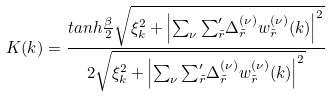Convert formula to latex. <formula><loc_0><loc_0><loc_500><loc_500>K ( { k } ) = \frac { t a n h \frac { \beta } { 2 } \sqrt { \xi ^ { 2 } _ { k } + \left | \sum _ { \nu } { \sum } ^ { \prime } _ { \tilde { r } } { \Delta _ { \tilde { r } } ^ { ( \nu ) } } w _ { \tilde { r } } ^ { ( \nu ) } ( { k } ) \right | ^ { 2 } } } { 2 \sqrt { \xi ^ { 2 } _ { k } + \left | \sum _ { \nu } { \sum } ^ { \prime } _ { \tilde { r } } { \Delta _ { \tilde { r } } ^ { ( \nu ) } } w _ { \tilde { r } } ^ { ( \nu ) } ( { k } ) \right | ^ { 2 } } }</formula> 